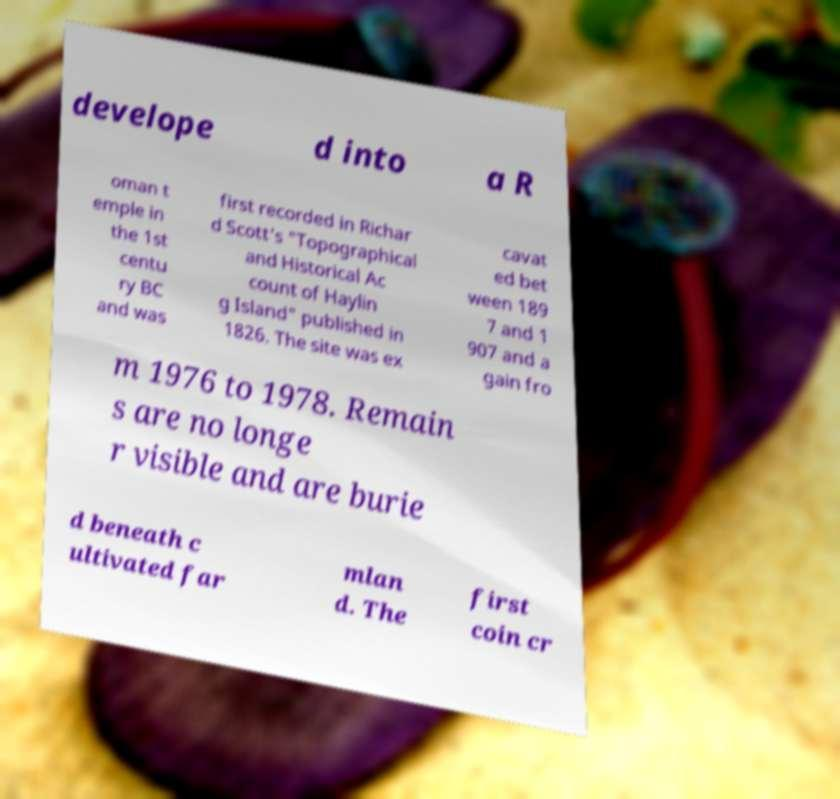Could you assist in decoding the text presented in this image and type it out clearly? develope d into a R oman t emple in the 1st centu ry BC and was first recorded in Richar d Scott's "Topographical and Historical Ac count of Haylin g Island" published in 1826. The site was ex cavat ed bet ween 189 7 and 1 907 and a gain fro m 1976 to 1978. Remain s are no longe r visible and are burie d beneath c ultivated far mlan d. The first coin cr 